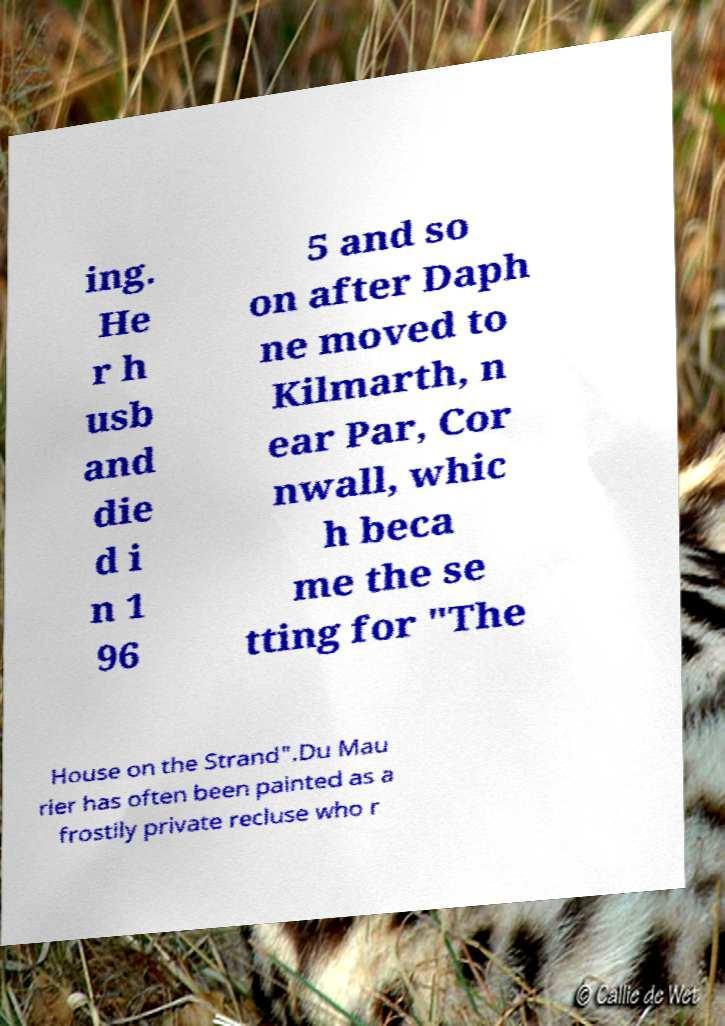Please read and relay the text visible in this image. What does it say? ing. He r h usb and die d i n 1 96 5 and so on after Daph ne moved to Kilmarth, n ear Par, Cor nwall, whic h beca me the se tting for "The House on the Strand".Du Mau rier has often been painted as a frostily private recluse who r 